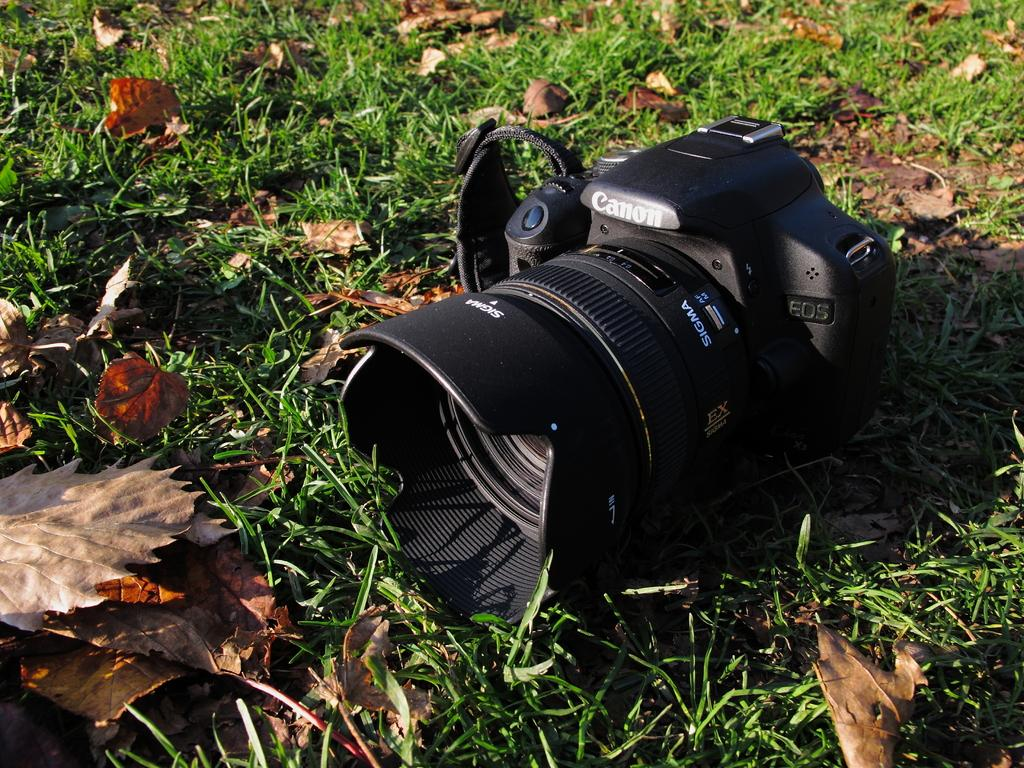What object is the main subject of the image? There is a camera in the image. Where is the camera located? The camera is on the grass. What type of natural elements can be seen in the image? There are leaves visible in the image. What type of minute songs can be heard being sung by the cook in the image? There is no cook or singing present in the image; it features a camera on the grass. 